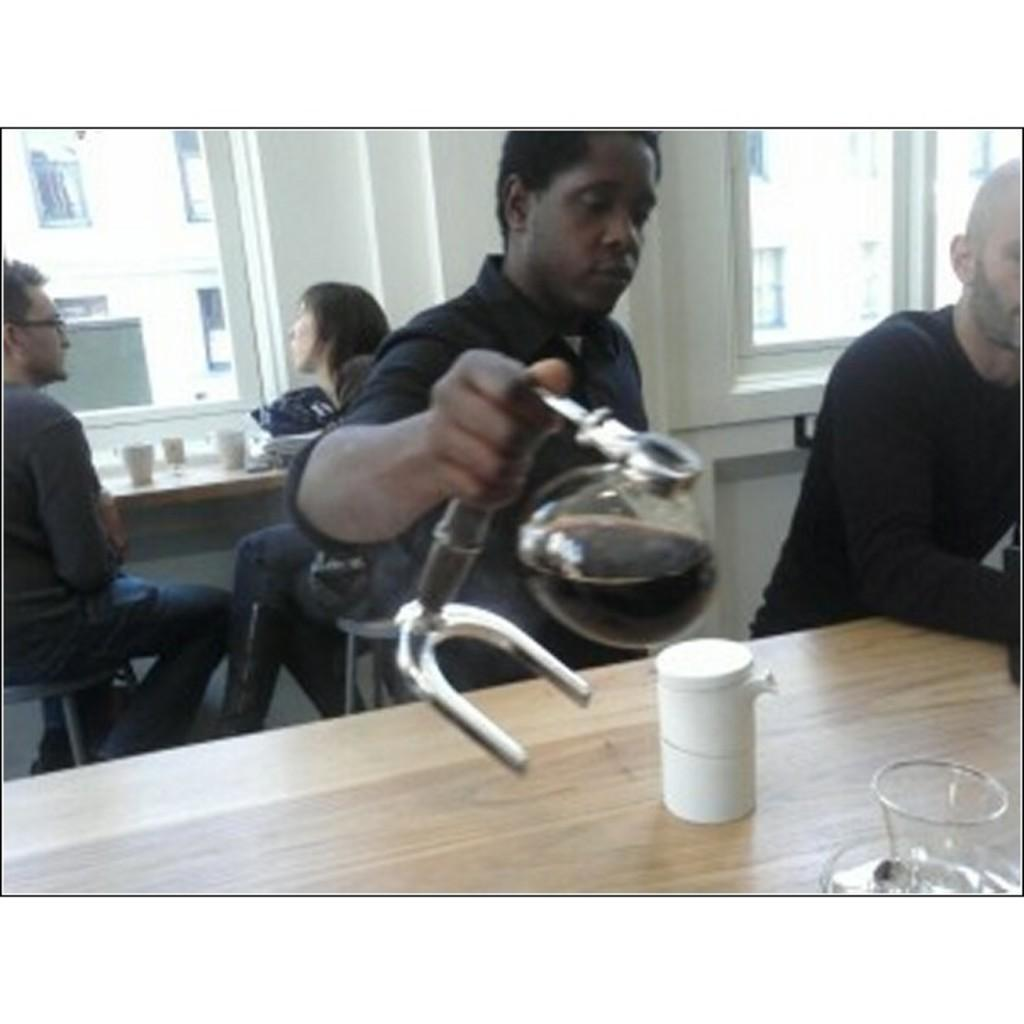How many people are present in the image? There are many people in the image. Can you describe the action of one of the people in the image? Yes, there is a person holding a jar in the image. What object can be seen in the image that might be used for serving or displaying items? There is a table in the image. What type of yarn is being pulled by the sun in the image? There is no sun or yarn present in the image. How does the sun affect the people in the image? The image does not show the sun or any direct effect on the people. 